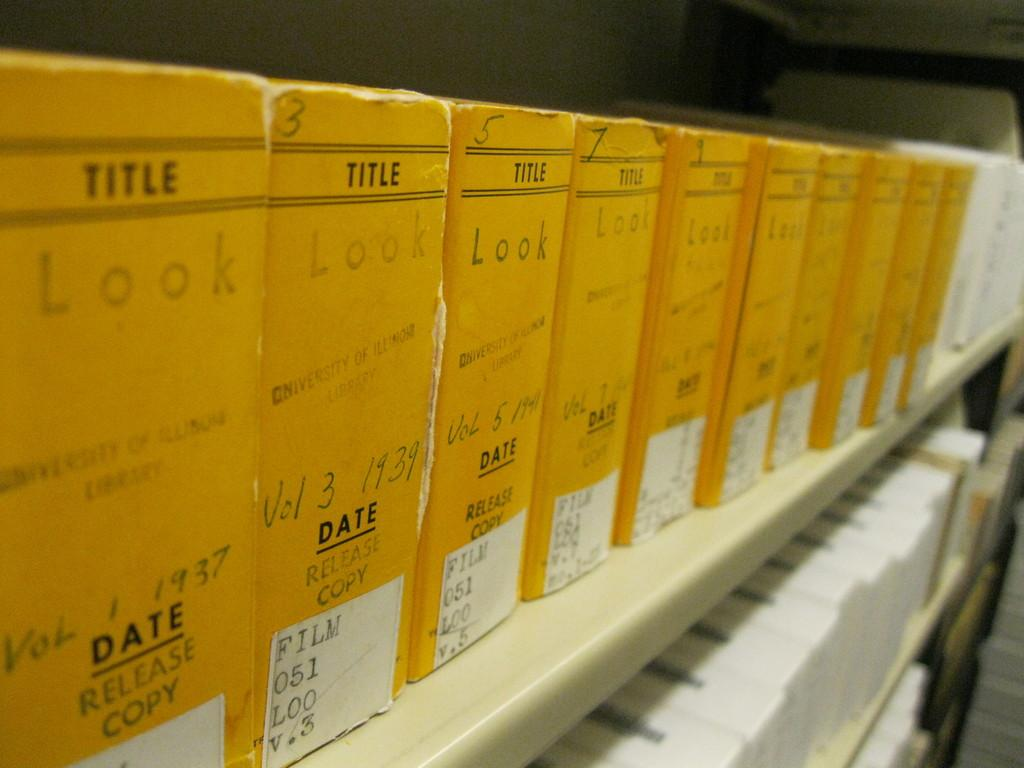<image>
Summarize the visual content of the image. All the volumes have the Title and date on them 